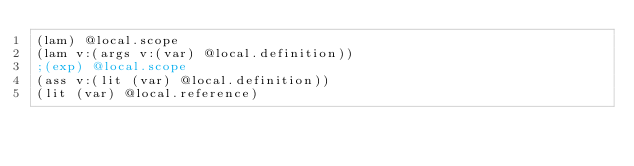<code> <loc_0><loc_0><loc_500><loc_500><_Scheme_>(lam) @local.scope
(lam v:(args v:(var) @local.definition))
;(exp) @local.scope
(ass v:(lit (var) @local.definition))
(lit (var) @local.reference)

</code> 